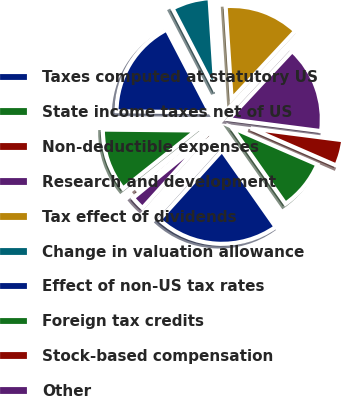Convert chart to OTSL. <chart><loc_0><loc_0><loc_500><loc_500><pie_chart><fcel>Taxes computed at statutory US<fcel>State income taxes net of US<fcel>Non-deductible expenses<fcel>Research and development<fcel>Tax effect of dividends<fcel>Change in valuation allowance<fcel>Effect of non-US tax rates<fcel>Foreign tax credits<fcel>Stock-based compensation<fcel>Other<nl><fcel>21.45%<fcel>8.73%<fcel>4.49%<fcel>15.09%<fcel>12.97%<fcel>6.61%<fcel>17.21%<fcel>10.85%<fcel>0.24%<fcel>2.36%<nl></chart> 